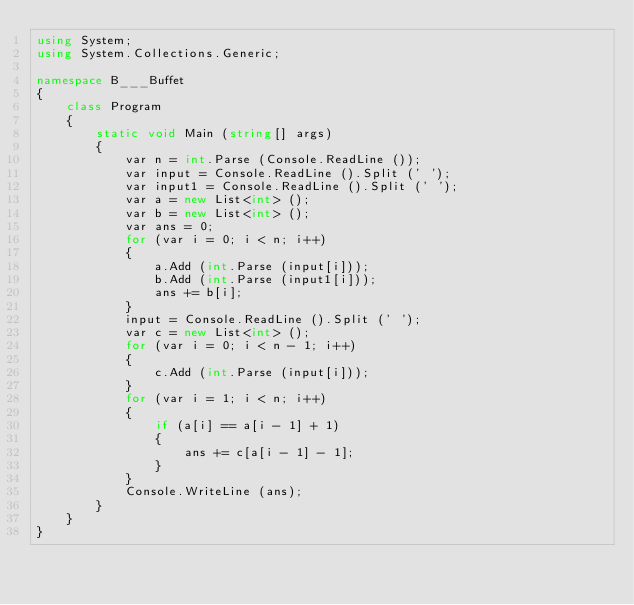<code> <loc_0><loc_0><loc_500><loc_500><_C#_>using System;
using System.Collections.Generic;

namespace B___Buffet
{
    class Program
    {
        static void Main (string[] args)
        {
            var n = int.Parse (Console.ReadLine ());
            var input = Console.ReadLine ().Split (' ');
            var input1 = Console.ReadLine ().Split (' ');
            var a = new List<int> ();
            var b = new List<int> ();
            var ans = 0;
            for (var i = 0; i < n; i++)
            {
                a.Add (int.Parse (input[i]));
                b.Add (int.Parse (input1[i]));
                ans += b[i];
            }
            input = Console.ReadLine ().Split (' ');
            var c = new List<int> ();
            for (var i = 0; i < n - 1; i++)
            {
                c.Add (int.Parse (input[i]));
            }
            for (var i = 1; i < n; i++)
            {
                if (a[i] == a[i - 1] + 1)
                {
                    ans += c[a[i - 1] - 1];
                }
            }
            Console.WriteLine (ans);
        }
    }
}</code> 